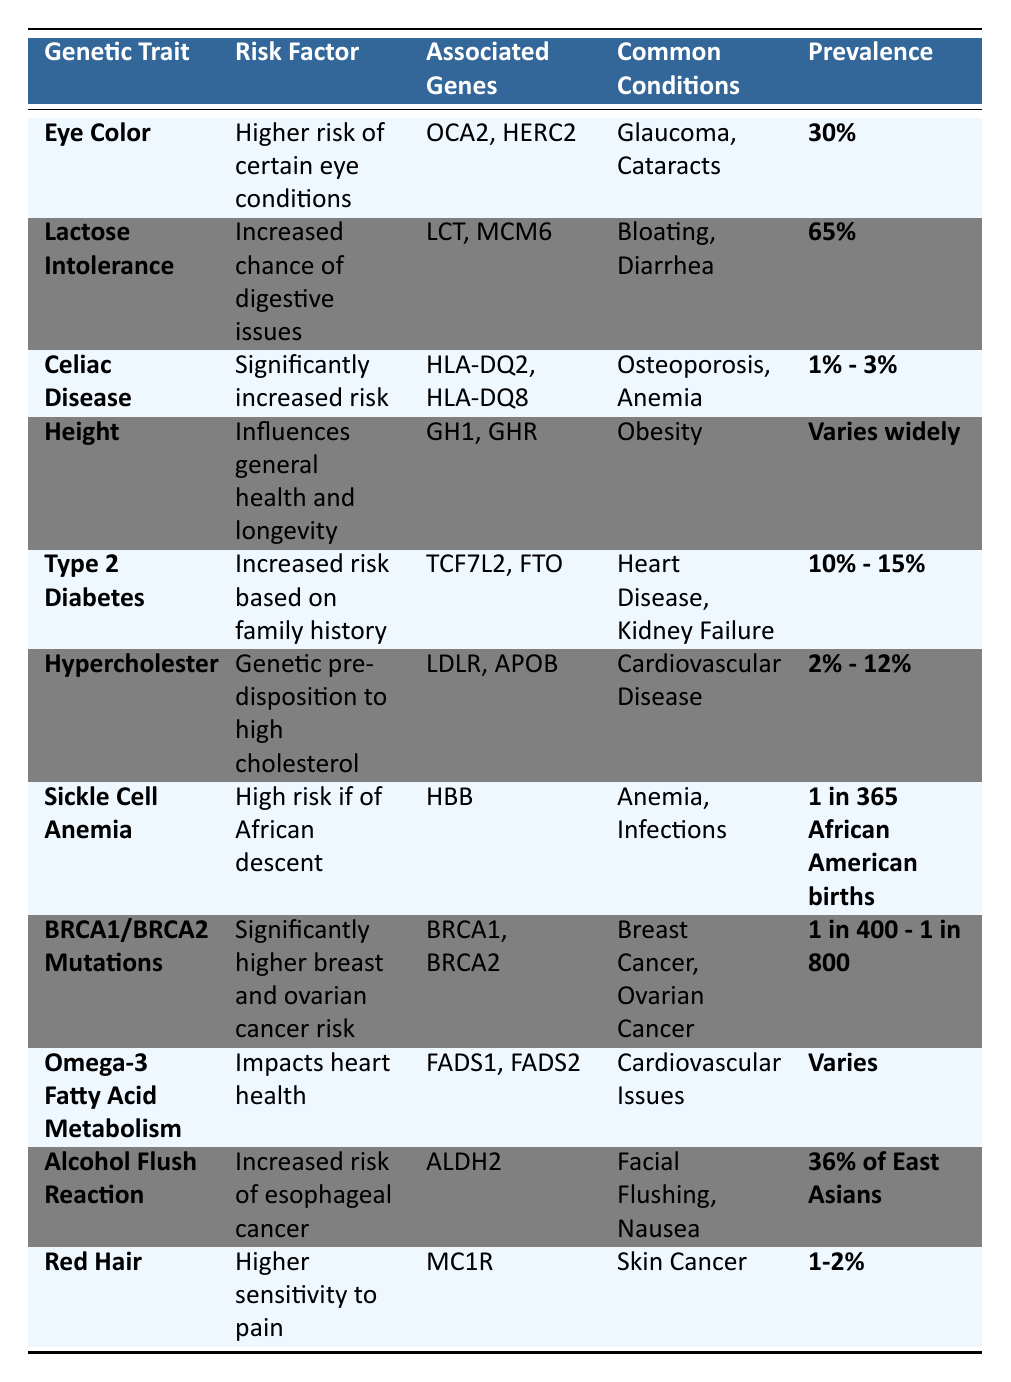What is the prevalence of Lactose Intolerance? The table specifies that the prevalence of Lactose Intolerance is **65%**.
Answer: 65% Which common condition is associated with Hypercholesterolemia? The common condition associated with Hypercholesterolemia is **Cardiovascular Disease**, as noted in the table.
Answer: Cardiovascular Disease Is the prevalence of Sickle Cell Anemia higher than that of Celiac Disease? The prevalence of Sickle Cell Anemia is **1 in 365 African American births** while Celiac Disease has a prevalence of **1% - 3%**. Since 1 in 365 is approximately 0.27%, Sickle Cell Anemia has a lower prevalence than Celiac Disease.
Answer: No What percentage of the population has an Alcohol Flush Reaction? According to the table, **36% of East Asians** experience an Alcohol Flush Reaction.
Answer: 36% What is the average prevalence between Type 2 Diabetes and Hypercholesterolemia? Type 2 Diabetes has a prevalence of **10% - 15%**, which averages to **12.5%**. Hypercholesterolemia’s range is **2% - 12%**, averaging to **7%**. So, the average of (12.5% + 7%) / 2 = 9.75%.
Answer: 9.75% Which trait has the highest prevalence according to the table? Lactose Intolerance has the highest prevalence at **65%** compared to other entries in the table.
Answer: Lactose Intolerance Are BRCA1/BRCA2 mutations associated with any specific cancers? Yes, they are associated with **Breast Cancer** and **Ovarian Cancer** as listed in the common conditions.
Answer: Yes What common condition is linked to Eye Color? The common conditions linked to Eye Color are **Glaucoma** and **Cataracts**, as shown in the table.
Answer: Glaucoma and Cataracts How many common conditions are associated with the trait of Red Hair? The table indicates that the common condition associated with Red Hair is **Skin Cancer**, implying there is **1** condition linked to it.
Answer: 1 Which traits have a prevalence that varies widely? The trait associated with a prevalence that varies widely is **Height**, as noted in the table.
Answer: Height Is it true that the associated genes for Celiac Disease include HLA-DQ2? Yes, the table lists **HLA-DQ2** and **HLA-DQ8** as associated genes for Celiac Disease.
Answer: Yes 